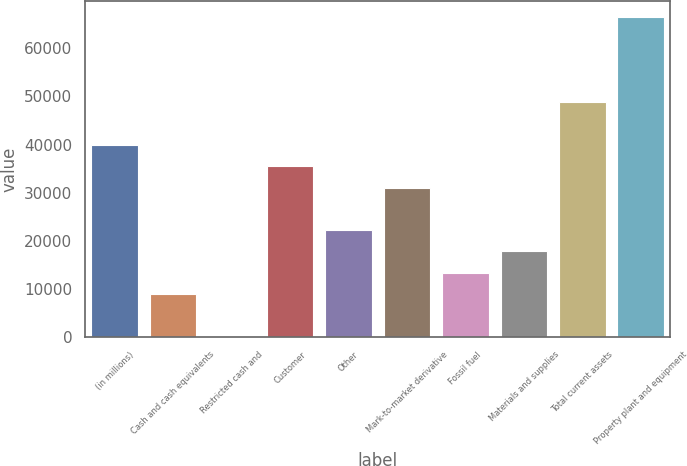Convert chart to OTSL. <chart><loc_0><loc_0><loc_500><loc_500><bar_chart><fcel>(in millions)<fcel>Cash and cash equivalents<fcel>Restricted cash and<fcel>Customer<fcel>Other<fcel>Mark-to-market derivative<fcel>Fossil fuel<fcel>Materials and supplies<fcel>Total current assets<fcel>Property plant and equipment<nl><fcel>39892.9<fcel>8910.2<fcel>58<fcel>35466.8<fcel>22188.5<fcel>31040.7<fcel>13336.3<fcel>17762.4<fcel>48745.1<fcel>66449.5<nl></chart> 